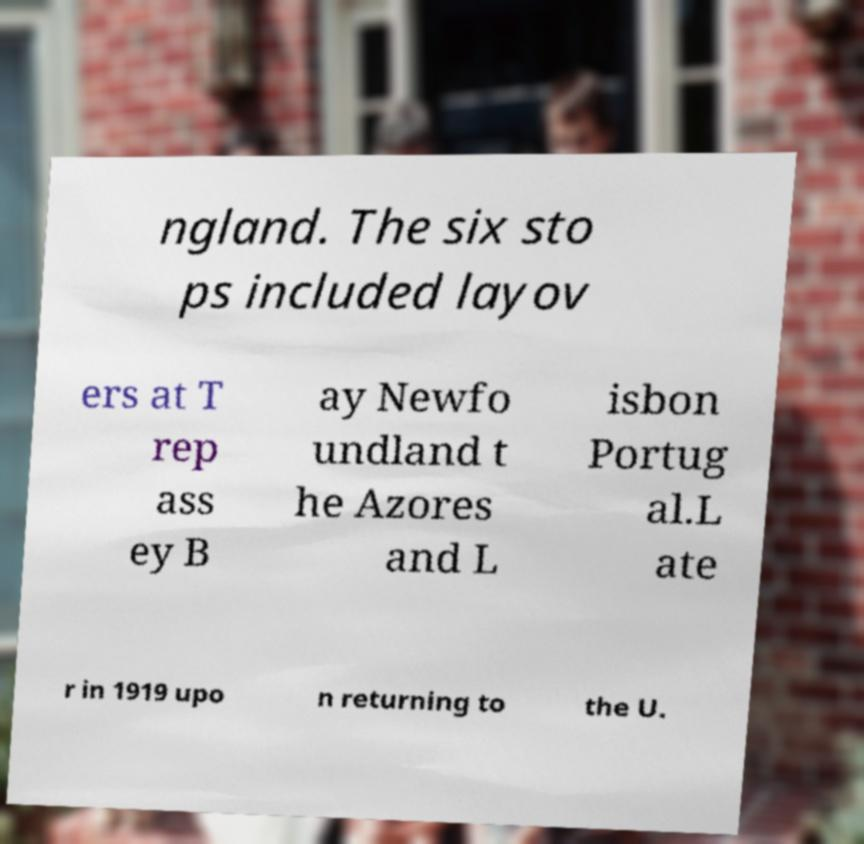Can you accurately transcribe the text from the provided image for me? ngland. The six sto ps included layov ers at T rep ass ey B ay Newfo undland t he Azores and L isbon Portug al.L ate r in 1919 upo n returning to the U. 